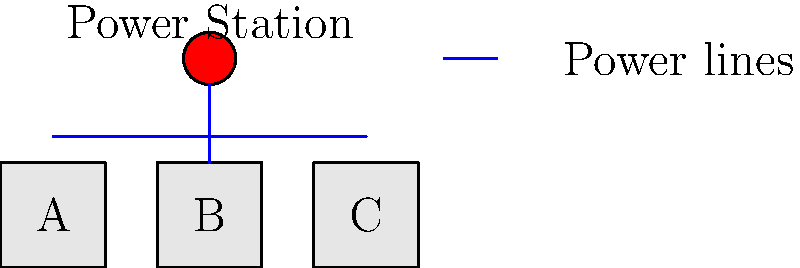In the electrical circuit layout for a new sports complex shown above, buildings A, B, and C need to be connected to the central power station. If the power consumption of buildings A, B, and C are 50 kW, 30 kW, and 40 kW respectively, what is the minimum cable cross-sectional area required for the main power line from the power station, assuming a maximum voltage drop of 2% and a cable resistivity of $1.72 \times 10^{-8} \, \Omega \cdot m$? To solve this problem, we'll follow these steps:

1) Calculate the total power consumption:
   $P_{total} = 50 \text{ kW} + 30 \text{ kW} + 40 \text{ kW} = 120 \text{ kW}$

2) Assume the supply voltage is 400V (standard three-phase voltage):
   $V = 400 \text{ V}$

3) Calculate the current using $P = VI$:
   $I = \frac{P}{V} = \frac{120,000 \text{ W}}{400 \text{ V}} = 300 \text{ A}$

4) The maximum allowed voltage drop is 2% of 400V:
   $\Delta V = 0.02 \times 400 \text{ V} = 8 \text{ V}$

5) Estimate the length of the main power line (from power station to point where it branches):
   $L \approx 1.5 \text{ m}$ (based on the diagram scale)

6) Use the voltage drop formula to calculate the required resistance:
   $\Delta V = IR$
   $R = \frac{\Delta V}{I} = \frac{8 \text{ V}}{300 \text{ A}} = 0.0267 \, \Omega$

7) Use the resistance formula to calculate the cross-sectional area:
   $R = \frac{\rho L}{A}$
   $A = \frac{\rho L}{R} = \frac{(1.72 \times 10^{-8} \, \Omega \cdot m)(1.5 \text{ m})}{0.0267 \, \Omega} = 9.66 \times 10^{-7} \text{ m}^2 = 0.966 \text{ mm}^2$

8) Round up to the nearest standard cable size, which would be 1 mm².
Answer: 1 mm² 